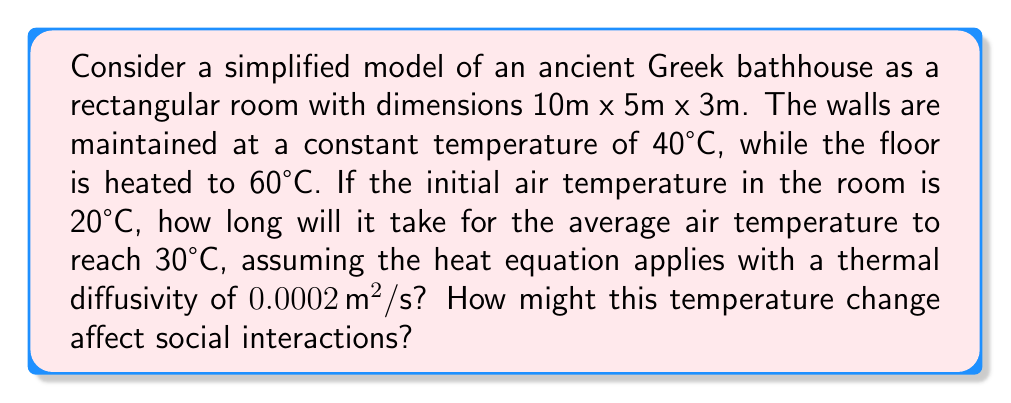Help me with this question. Let's approach this problem step-by-step:

1) The heat equation in 3D is given by:

   $$\frac{\partial u}{\partial t} = \alpha \left(\frac{\partial^2 u}{\partial x^2} + \frac{\partial^2 u}{\partial y^2} + \frac{\partial^2 u}{\partial z^2}\right)$$

   where $u$ is temperature, $t$ is time, and $\alpha$ is thermal diffusivity.

2) For a rough estimation, we can use the characteristic time scale of heat diffusion:

   $$t \approx \frac{L^2}{\alpha}$$

   where $L$ is the characteristic length scale.

3) In this case, we'll use the smallest dimension (height) as our characteristic length:
   $L = 3\text{m}$

4) Plugging in the values:

   $$t \approx \frac{(3\text{m})^2}{0.0002 \, \text{m}^2/\text{s}} = 45000\text{s} \approx 12.5\text{hours}$$

5) This gives us a rough estimate of how long it takes for heat to diffuse through the room.

6) To estimate the time to reach 30°C, we can use Newton's law of cooling:

   $$T(t) = T_s + (T_0 - T_s)e^{-kt}$$

   where $T_s$ is the surrounding temperature (average of wall and floor temperatures),
   $T_0$ is the initial temperature, and $k$ is a cooling constant.

7) $T_s = (40°C \times 5 + 60°C)/6 = 43.33°C$ (weighted average of wall and floor temperatures)

8) We can estimate $k$ using the characteristic time:
   $k \approx 1/45000\text{s}^{-1} = 2.22 \times 10^{-5}\text{s}^{-1}$

9) Solving for $t$ when $T(t) = 30°C$:

   $$30 = 43.33 + (20 - 43.33)e^{-2.22 \times 10^{-5}t}$$
   $$e^{-2.22 \times 10^{-5}t} = \frac{30 - 43.33}{20 - 43.33} = 0.57$$
   $$t = -\frac{\ln(0.57)}{2.22 \times 10^{-5}} \approx 25000\text{s} \approx 7\text{hours}$$

This gradual increase in temperature over several hours would likely promote longer, more relaxed social interactions as people stayed to enjoy the warmth, potentially leading to more in-depth conversations and stronger social bonds.
Answer: Approximately 7 hours to reach 30°C, promoting longer and more relaxed social interactions. 